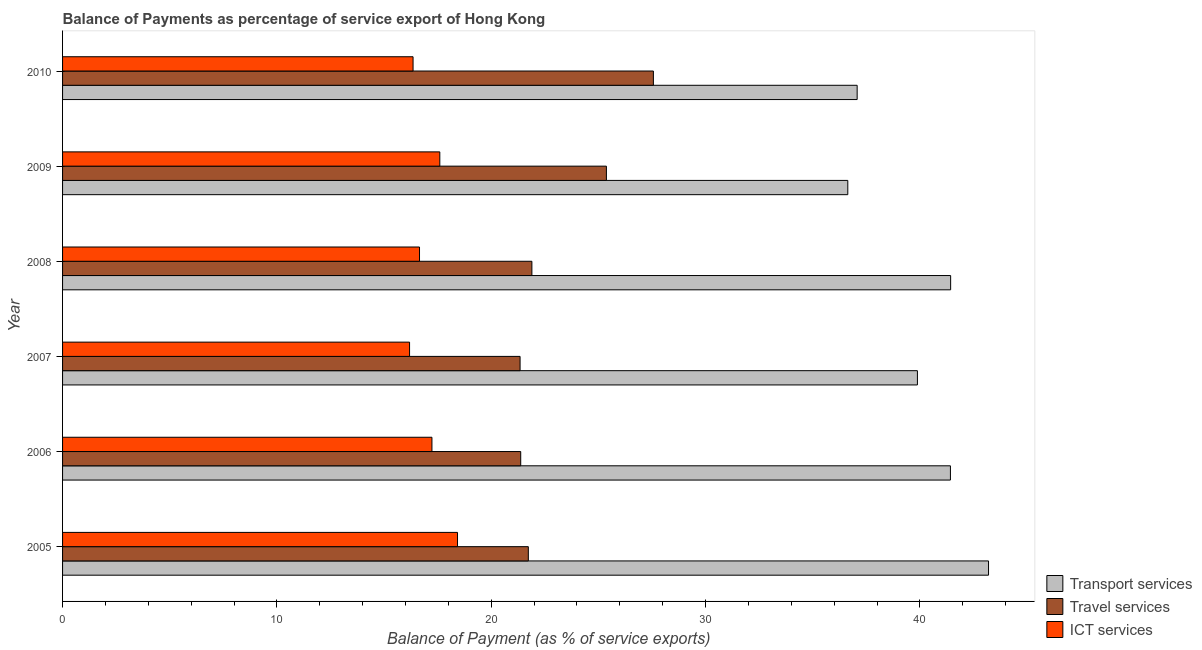How many groups of bars are there?
Provide a short and direct response. 6. Are the number of bars on each tick of the Y-axis equal?
Your answer should be very brief. Yes. How many bars are there on the 6th tick from the top?
Offer a terse response. 3. How many bars are there on the 2nd tick from the bottom?
Your answer should be compact. 3. What is the balance of payment of transport services in 2010?
Your answer should be very brief. 37.07. Across all years, what is the maximum balance of payment of ict services?
Give a very brief answer. 18.43. Across all years, what is the minimum balance of payment of ict services?
Your answer should be compact. 16.19. In which year was the balance of payment of transport services maximum?
Your answer should be very brief. 2005. In which year was the balance of payment of travel services minimum?
Provide a succinct answer. 2007. What is the total balance of payment of ict services in the graph?
Provide a succinct answer. 102.45. What is the difference between the balance of payment of transport services in 2005 and that in 2008?
Ensure brevity in your answer.  1.77. What is the difference between the balance of payment of transport services in 2006 and the balance of payment of travel services in 2008?
Give a very brief answer. 19.53. What is the average balance of payment of travel services per year?
Provide a short and direct response. 23.21. In the year 2010, what is the difference between the balance of payment of transport services and balance of payment of travel services?
Ensure brevity in your answer.  9.51. In how many years, is the balance of payment of ict services greater than 32 %?
Keep it short and to the point. 0. What is the ratio of the balance of payment of travel services in 2009 to that in 2010?
Your answer should be compact. 0.92. Is the difference between the balance of payment of transport services in 2006 and 2007 greater than the difference between the balance of payment of ict services in 2006 and 2007?
Make the answer very short. Yes. What is the difference between the highest and the second highest balance of payment of travel services?
Offer a terse response. 2.19. What is the difference between the highest and the lowest balance of payment of transport services?
Your response must be concise. 6.57. Is the sum of the balance of payment of transport services in 2006 and 2008 greater than the maximum balance of payment of travel services across all years?
Ensure brevity in your answer.  Yes. What does the 3rd bar from the top in 2006 represents?
Make the answer very short. Transport services. What does the 3rd bar from the bottom in 2005 represents?
Keep it short and to the point. ICT services. Is it the case that in every year, the sum of the balance of payment of transport services and balance of payment of travel services is greater than the balance of payment of ict services?
Keep it short and to the point. Yes. How many years are there in the graph?
Offer a very short reply. 6. What is the difference between two consecutive major ticks on the X-axis?
Your answer should be very brief. 10. Does the graph contain any zero values?
Give a very brief answer. No. Does the graph contain grids?
Give a very brief answer. No. How are the legend labels stacked?
Provide a short and direct response. Vertical. What is the title of the graph?
Your answer should be very brief. Balance of Payments as percentage of service export of Hong Kong. Does "Grants" appear as one of the legend labels in the graph?
Provide a short and direct response. No. What is the label or title of the X-axis?
Keep it short and to the point. Balance of Payment (as % of service exports). What is the label or title of the Y-axis?
Your response must be concise. Year. What is the Balance of Payment (as % of service exports) in Transport services in 2005?
Provide a succinct answer. 43.2. What is the Balance of Payment (as % of service exports) in Travel services in 2005?
Ensure brevity in your answer.  21.73. What is the Balance of Payment (as % of service exports) of ICT services in 2005?
Ensure brevity in your answer.  18.43. What is the Balance of Payment (as % of service exports) of Transport services in 2006?
Provide a succinct answer. 41.42. What is the Balance of Payment (as % of service exports) in Travel services in 2006?
Your response must be concise. 21.37. What is the Balance of Payment (as % of service exports) in ICT services in 2006?
Offer a very short reply. 17.23. What is the Balance of Payment (as % of service exports) in Transport services in 2007?
Provide a short and direct response. 39.88. What is the Balance of Payment (as % of service exports) in Travel services in 2007?
Ensure brevity in your answer.  21.34. What is the Balance of Payment (as % of service exports) in ICT services in 2007?
Provide a succinct answer. 16.19. What is the Balance of Payment (as % of service exports) of Transport services in 2008?
Make the answer very short. 41.43. What is the Balance of Payment (as % of service exports) of Travel services in 2008?
Offer a terse response. 21.9. What is the Balance of Payment (as % of service exports) in ICT services in 2008?
Provide a succinct answer. 16.65. What is the Balance of Payment (as % of service exports) of Transport services in 2009?
Keep it short and to the point. 36.63. What is the Balance of Payment (as % of service exports) of Travel services in 2009?
Provide a succinct answer. 25.37. What is the Balance of Payment (as % of service exports) in ICT services in 2009?
Your answer should be very brief. 17.6. What is the Balance of Payment (as % of service exports) in Transport services in 2010?
Your answer should be very brief. 37.07. What is the Balance of Payment (as % of service exports) in Travel services in 2010?
Offer a very short reply. 27.56. What is the Balance of Payment (as % of service exports) of ICT services in 2010?
Ensure brevity in your answer.  16.35. Across all years, what is the maximum Balance of Payment (as % of service exports) in Transport services?
Ensure brevity in your answer.  43.2. Across all years, what is the maximum Balance of Payment (as % of service exports) of Travel services?
Offer a very short reply. 27.56. Across all years, what is the maximum Balance of Payment (as % of service exports) of ICT services?
Make the answer very short. 18.43. Across all years, what is the minimum Balance of Payment (as % of service exports) in Transport services?
Ensure brevity in your answer.  36.63. Across all years, what is the minimum Balance of Payment (as % of service exports) of Travel services?
Your answer should be compact. 21.34. Across all years, what is the minimum Balance of Payment (as % of service exports) of ICT services?
Ensure brevity in your answer.  16.19. What is the total Balance of Payment (as % of service exports) of Transport services in the graph?
Your response must be concise. 239.64. What is the total Balance of Payment (as % of service exports) in Travel services in the graph?
Provide a succinct answer. 139.28. What is the total Balance of Payment (as % of service exports) of ICT services in the graph?
Your response must be concise. 102.45. What is the difference between the Balance of Payment (as % of service exports) in Transport services in 2005 and that in 2006?
Provide a short and direct response. 1.78. What is the difference between the Balance of Payment (as % of service exports) in Travel services in 2005 and that in 2006?
Your response must be concise. 0.36. What is the difference between the Balance of Payment (as % of service exports) in ICT services in 2005 and that in 2006?
Your response must be concise. 1.19. What is the difference between the Balance of Payment (as % of service exports) in Transport services in 2005 and that in 2007?
Give a very brief answer. 3.32. What is the difference between the Balance of Payment (as % of service exports) of Travel services in 2005 and that in 2007?
Give a very brief answer. 0.39. What is the difference between the Balance of Payment (as % of service exports) in ICT services in 2005 and that in 2007?
Your answer should be compact. 2.24. What is the difference between the Balance of Payment (as % of service exports) of Transport services in 2005 and that in 2008?
Keep it short and to the point. 1.77. What is the difference between the Balance of Payment (as % of service exports) in Travel services in 2005 and that in 2008?
Offer a very short reply. -0.17. What is the difference between the Balance of Payment (as % of service exports) in ICT services in 2005 and that in 2008?
Offer a terse response. 1.77. What is the difference between the Balance of Payment (as % of service exports) of Transport services in 2005 and that in 2009?
Your answer should be compact. 6.57. What is the difference between the Balance of Payment (as % of service exports) of Travel services in 2005 and that in 2009?
Give a very brief answer. -3.64. What is the difference between the Balance of Payment (as % of service exports) in ICT services in 2005 and that in 2009?
Your response must be concise. 0.83. What is the difference between the Balance of Payment (as % of service exports) of Transport services in 2005 and that in 2010?
Offer a very short reply. 6.13. What is the difference between the Balance of Payment (as % of service exports) of Travel services in 2005 and that in 2010?
Provide a succinct answer. -5.83. What is the difference between the Balance of Payment (as % of service exports) of ICT services in 2005 and that in 2010?
Ensure brevity in your answer.  2.07. What is the difference between the Balance of Payment (as % of service exports) of Transport services in 2006 and that in 2007?
Your answer should be compact. 1.54. What is the difference between the Balance of Payment (as % of service exports) in Travel services in 2006 and that in 2007?
Provide a short and direct response. 0.03. What is the difference between the Balance of Payment (as % of service exports) in ICT services in 2006 and that in 2007?
Keep it short and to the point. 1.04. What is the difference between the Balance of Payment (as % of service exports) of Transport services in 2006 and that in 2008?
Ensure brevity in your answer.  -0.01. What is the difference between the Balance of Payment (as % of service exports) of Travel services in 2006 and that in 2008?
Make the answer very short. -0.52. What is the difference between the Balance of Payment (as % of service exports) in ICT services in 2006 and that in 2008?
Ensure brevity in your answer.  0.58. What is the difference between the Balance of Payment (as % of service exports) of Transport services in 2006 and that in 2009?
Your response must be concise. 4.79. What is the difference between the Balance of Payment (as % of service exports) in Travel services in 2006 and that in 2009?
Make the answer very short. -4. What is the difference between the Balance of Payment (as % of service exports) of ICT services in 2006 and that in 2009?
Ensure brevity in your answer.  -0.37. What is the difference between the Balance of Payment (as % of service exports) in Transport services in 2006 and that in 2010?
Give a very brief answer. 4.35. What is the difference between the Balance of Payment (as % of service exports) in Travel services in 2006 and that in 2010?
Provide a short and direct response. -6.19. What is the difference between the Balance of Payment (as % of service exports) of ICT services in 2006 and that in 2010?
Offer a very short reply. 0.88. What is the difference between the Balance of Payment (as % of service exports) in Transport services in 2007 and that in 2008?
Keep it short and to the point. -1.55. What is the difference between the Balance of Payment (as % of service exports) in Travel services in 2007 and that in 2008?
Your answer should be compact. -0.55. What is the difference between the Balance of Payment (as % of service exports) of ICT services in 2007 and that in 2008?
Provide a short and direct response. -0.46. What is the difference between the Balance of Payment (as % of service exports) of Transport services in 2007 and that in 2009?
Your response must be concise. 3.25. What is the difference between the Balance of Payment (as % of service exports) of Travel services in 2007 and that in 2009?
Provide a succinct answer. -4.03. What is the difference between the Balance of Payment (as % of service exports) in ICT services in 2007 and that in 2009?
Make the answer very short. -1.41. What is the difference between the Balance of Payment (as % of service exports) of Transport services in 2007 and that in 2010?
Your answer should be compact. 2.81. What is the difference between the Balance of Payment (as % of service exports) in Travel services in 2007 and that in 2010?
Offer a terse response. -6.22. What is the difference between the Balance of Payment (as % of service exports) in ICT services in 2007 and that in 2010?
Provide a short and direct response. -0.16. What is the difference between the Balance of Payment (as % of service exports) in Transport services in 2008 and that in 2009?
Make the answer very short. 4.8. What is the difference between the Balance of Payment (as % of service exports) in Travel services in 2008 and that in 2009?
Offer a very short reply. -3.48. What is the difference between the Balance of Payment (as % of service exports) in ICT services in 2008 and that in 2009?
Offer a very short reply. -0.95. What is the difference between the Balance of Payment (as % of service exports) in Transport services in 2008 and that in 2010?
Your response must be concise. 4.36. What is the difference between the Balance of Payment (as % of service exports) of Travel services in 2008 and that in 2010?
Provide a short and direct response. -5.67. What is the difference between the Balance of Payment (as % of service exports) in ICT services in 2008 and that in 2010?
Provide a short and direct response. 0.3. What is the difference between the Balance of Payment (as % of service exports) in Transport services in 2009 and that in 2010?
Your response must be concise. -0.44. What is the difference between the Balance of Payment (as % of service exports) in Travel services in 2009 and that in 2010?
Your answer should be compact. -2.19. What is the difference between the Balance of Payment (as % of service exports) of ICT services in 2009 and that in 2010?
Make the answer very short. 1.25. What is the difference between the Balance of Payment (as % of service exports) in Transport services in 2005 and the Balance of Payment (as % of service exports) in Travel services in 2006?
Ensure brevity in your answer.  21.83. What is the difference between the Balance of Payment (as % of service exports) in Transport services in 2005 and the Balance of Payment (as % of service exports) in ICT services in 2006?
Provide a succinct answer. 25.97. What is the difference between the Balance of Payment (as % of service exports) of Travel services in 2005 and the Balance of Payment (as % of service exports) of ICT services in 2006?
Provide a short and direct response. 4.5. What is the difference between the Balance of Payment (as % of service exports) in Transport services in 2005 and the Balance of Payment (as % of service exports) in Travel services in 2007?
Offer a terse response. 21.86. What is the difference between the Balance of Payment (as % of service exports) of Transport services in 2005 and the Balance of Payment (as % of service exports) of ICT services in 2007?
Provide a succinct answer. 27.01. What is the difference between the Balance of Payment (as % of service exports) in Travel services in 2005 and the Balance of Payment (as % of service exports) in ICT services in 2007?
Provide a succinct answer. 5.54. What is the difference between the Balance of Payment (as % of service exports) of Transport services in 2005 and the Balance of Payment (as % of service exports) of Travel services in 2008?
Your answer should be very brief. 21.3. What is the difference between the Balance of Payment (as % of service exports) in Transport services in 2005 and the Balance of Payment (as % of service exports) in ICT services in 2008?
Keep it short and to the point. 26.55. What is the difference between the Balance of Payment (as % of service exports) of Travel services in 2005 and the Balance of Payment (as % of service exports) of ICT services in 2008?
Your response must be concise. 5.08. What is the difference between the Balance of Payment (as % of service exports) of Transport services in 2005 and the Balance of Payment (as % of service exports) of Travel services in 2009?
Your answer should be very brief. 17.83. What is the difference between the Balance of Payment (as % of service exports) of Transport services in 2005 and the Balance of Payment (as % of service exports) of ICT services in 2009?
Keep it short and to the point. 25.6. What is the difference between the Balance of Payment (as % of service exports) in Travel services in 2005 and the Balance of Payment (as % of service exports) in ICT services in 2009?
Offer a very short reply. 4.13. What is the difference between the Balance of Payment (as % of service exports) of Transport services in 2005 and the Balance of Payment (as % of service exports) of Travel services in 2010?
Your answer should be very brief. 15.64. What is the difference between the Balance of Payment (as % of service exports) of Transport services in 2005 and the Balance of Payment (as % of service exports) of ICT services in 2010?
Keep it short and to the point. 26.85. What is the difference between the Balance of Payment (as % of service exports) of Travel services in 2005 and the Balance of Payment (as % of service exports) of ICT services in 2010?
Offer a very short reply. 5.38. What is the difference between the Balance of Payment (as % of service exports) of Transport services in 2006 and the Balance of Payment (as % of service exports) of Travel services in 2007?
Your answer should be compact. 20.08. What is the difference between the Balance of Payment (as % of service exports) of Transport services in 2006 and the Balance of Payment (as % of service exports) of ICT services in 2007?
Give a very brief answer. 25.23. What is the difference between the Balance of Payment (as % of service exports) in Travel services in 2006 and the Balance of Payment (as % of service exports) in ICT services in 2007?
Offer a terse response. 5.19. What is the difference between the Balance of Payment (as % of service exports) of Transport services in 2006 and the Balance of Payment (as % of service exports) of Travel services in 2008?
Provide a succinct answer. 19.53. What is the difference between the Balance of Payment (as % of service exports) of Transport services in 2006 and the Balance of Payment (as % of service exports) of ICT services in 2008?
Ensure brevity in your answer.  24.77. What is the difference between the Balance of Payment (as % of service exports) in Travel services in 2006 and the Balance of Payment (as % of service exports) in ICT services in 2008?
Your answer should be compact. 4.72. What is the difference between the Balance of Payment (as % of service exports) in Transport services in 2006 and the Balance of Payment (as % of service exports) in Travel services in 2009?
Provide a succinct answer. 16.05. What is the difference between the Balance of Payment (as % of service exports) of Transport services in 2006 and the Balance of Payment (as % of service exports) of ICT services in 2009?
Keep it short and to the point. 23.82. What is the difference between the Balance of Payment (as % of service exports) of Travel services in 2006 and the Balance of Payment (as % of service exports) of ICT services in 2009?
Provide a succinct answer. 3.77. What is the difference between the Balance of Payment (as % of service exports) in Transport services in 2006 and the Balance of Payment (as % of service exports) in Travel services in 2010?
Provide a succinct answer. 13.86. What is the difference between the Balance of Payment (as % of service exports) in Transport services in 2006 and the Balance of Payment (as % of service exports) in ICT services in 2010?
Provide a short and direct response. 25.07. What is the difference between the Balance of Payment (as % of service exports) of Travel services in 2006 and the Balance of Payment (as % of service exports) of ICT services in 2010?
Provide a short and direct response. 5.02. What is the difference between the Balance of Payment (as % of service exports) of Transport services in 2007 and the Balance of Payment (as % of service exports) of Travel services in 2008?
Offer a terse response. 17.99. What is the difference between the Balance of Payment (as % of service exports) in Transport services in 2007 and the Balance of Payment (as % of service exports) in ICT services in 2008?
Provide a short and direct response. 23.23. What is the difference between the Balance of Payment (as % of service exports) of Travel services in 2007 and the Balance of Payment (as % of service exports) of ICT services in 2008?
Your answer should be compact. 4.69. What is the difference between the Balance of Payment (as % of service exports) of Transport services in 2007 and the Balance of Payment (as % of service exports) of Travel services in 2009?
Make the answer very short. 14.51. What is the difference between the Balance of Payment (as % of service exports) in Transport services in 2007 and the Balance of Payment (as % of service exports) in ICT services in 2009?
Provide a succinct answer. 22.28. What is the difference between the Balance of Payment (as % of service exports) of Travel services in 2007 and the Balance of Payment (as % of service exports) of ICT services in 2009?
Make the answer very short. 3.75. What is the difference between the Balance of Payment (as % of service exports) of Transport services in 2007 and the Balance of Payment (as % of service exports) of Travel services in 2010?
Provide a succinct answer. 12.32. What is the difference between the Balance of Payment (as % of service exports) in Transport services in 2007 and the Balance of Payment (as % of service exports) in ICT services in 2010?
Your answer should be compact. 23.53. What is the difference between the Balance of Payment (as % of service exports) in Travel services in 2007 and the Balance of Payment (as % of service exports) in ICT services in 2010?
Provide a short and direct response. 4.99. What is the difference between the Balance of Payment (as % of service exports) in Transport services in 2008 and the Balance of Payment (as % of service exports) in Travel services in 2009?
Provide a succinct answer. 16.06. What is the difference between the Balance of Payment (as % of service exports) of Transport services in 2008 and the Balance of Payment (as % of service exports) of ICT services in 2009?
Ensure brevity in your answer.  23.83. What is the difference between the Balance of Payment (as % of service exports) in Travel services in 2008 and the Balance of Payment (as % of service exports) in ICT services in 2009?
Give a very brief answer. 4.3. What is the difference between the Balance of Payment (as % of service exports) in Transport services in 2008 and the Balance of Payment (as % of service exports) in Travel services in 2010?
Keep it short and to the point. 13.87. What is the difference between the Balance of Payment (as % of service exports) of Transport services in 2008 and the Balance of Payment (as % of service exports) of ICT services in 2010?
Ensure brevity in your answer.  25.08. What is the difference between the Balance of Payment (as % of service exports) in Travel services in 2008 and the Balance of Payment (as % of service exports) in ICT services in 2010?
Offer a terse response. 5.54. What is the difference between the Balance of Payment (as % of service exports) of Transport services in 2009 and the Balance of Payment (as % of service exports) of Travel services in 2010?
Your response must be concise. 9.07. What is the difference between the Balance of Payment (as % of service exports) of Transport services in 2009 and the Balance of Payment (as % of service exports) of ICT services in 2010?
Make the answer very short. 20.28. What is the difference between the Balance of Payment (as % of service exports) in Travel services in 2009 and the Balance of Payment (as % of service exports) in ICT services in 2010?
Offer a very short reply. 9.02. What is the average Balance of Payment (as % of service exports) in Transport services per year?
Make the answer very short. 39.94. What is the average Balance of Payment (as % of service exports) of Travel services per year?
Your answer should be compact. 23.21. What is the average Balance of Payment (as % of service exports) of ICT services per year?
Provide a succinct answer. 17.08. In the year 2005, what is the difference between the Balance of Payment (as % of service exports) of Transport services and Balance of Payment (as % of service exports) of Travel services?
Your answer should be very brief. 21.47. In the year 2005, what is the difference between the Balance of Payment (as % of service exports) in Transport services and Balance of Payment (as % of service exports) in ICT services?
Your answer should be very brief. 24.77. In the year 2005, what is the difference between the Balance of Payment (as % of service exports) of Travel services and Balance of Payment (as % of service exports) of ICT services?
Offer a terse response. 3.3. In the year 2006, what is the difference between the Balance of Payment (as % of service exports) of Transport services and Balance of Payment (as % of service exports) of Travel services?
Provide a short and direct response. 20.05. In the year 2006, what is the difference between the Balance of Payment (as % of service exports) of Transport services and Balance of Payment (as % of service exports) of ICT services?
Make the answer very short. 24.19. In the year 2006, what is the difference between the Balance of Payment (as % of service exports) in Travel services and Balance of Payment (as % of service exports) in ICT services?
Your answer should be very brief. 4.14. In the year 2007, what is the difference between the Balance of Payment (as % of service exports) in Transport services and Balance of Payment (as % of service exports) in Travel services?
Provide a short and direct response. 18.54. In the year 2007, what is the difference between the Balance of Payment (as % of service exports) in Transport services and Balance of Payment (as % of service exports) in ICT services?
Keep it short and to the point. 23.69. In the year 2007, what is the difference between the Balance of Payment (as % of service exports) in Travel services and Balance of Payment (as % of service exports) in ICT services?
Make the answer very short. 5.16. In the year 2008, what is the difference between the Balance of Payment (as % of service exports) in Transport services and Balance of Payment (as % of service exports) in Travel services?
Offer a terse response. 19.54. In the year 2008, what is the difference between the Balance of Payment (as % of service exports) in Transport services and Balance of Payment (as % of service exports) in ICT services?
Provide a succinct answer. 24.78. In the year 2008, what is the difference between the Balance of Payment (as % of service exports) of Travel services and Balance of Payment (as % of service exports) of ICT services?
Your answer should be compact. 5.24. In the year 2009, what is the difference between the Balance of Payment (as % of service exports) of Transport services and Balance of Payment (as % of service exports) of Travel services?
Provide a short and direct response. 11.26. In the year 2009, what is the difference between the Balance of Payment (as % of service exports) in Transport services and Balance of Payment (as % of service exports) in ICT services?
Provide a short and direct response. 19.03. In the year 2009, what is the difference between the Balance of Payment (as % of service exports) of Travel services and Balance of Payment (as % of service exports) of ICT services?
Your answer should be very brief. 7.77. In the year 2010, what is the difference between the Balance of Payment (as % of service exports) of Transport services and Balance of Payment (as % of service exports) of Travel services?
Your answer should be compact. 9.51. In the year 2010, what is the difference between the Balance of Payment (as % of service exports) in Transport services and Balance of Payment (as % of service exports) in ICT services?
Offer a very short reply. 20.72. In the year 2010, what is the difference between the Balance of Payment (as % of service exports) of Travel services and Balance of Payment (as % of service exports) of ICT services?
Make the answer very short. 11.21. What is the ratio of the Balance of Payment (as % of service exports) in Transport services in 2005 to that in 2006?
Your answer should be compact. 1.04. What is the ratio of the Balance of Payment (as % of service exports) in Travel services in 2005 to that in 2006?
Offer a very short reply. 1.02. What is the ratio of the Balance of Payment (as % of service exports) in ICT services in 2005 to that in 2006?
Your answer should be very brief. 1.07. What is the ratio of the Balance of Payment (as % of service exports) of Transport services in 2005 to that in 2007?
Your response must be concise. 1.08. What is the ratio of the Balance of Payment (as % of service exports) in ICT services in 2005 to that in 2007?
Your answer should be very brief. 1.14. What is the ratio of the Balance of Payment (as % of service exports) in Transport services in 2005 to that in 2008?
Ensure brevity in your answer.  1.04. What is the ratio of the Balance of Payment (as % of service exports) of Travel services in 2005 to that in 2008?
Your answer should be very brief. 0.99. What is the ratio of the Balance of Payment (as % of service exports) in ICT services in 2005 to that in 2008?
Provide a short and direct response. 1.11. What is the ratio of the Balance of Payment (as % of service exports) in Transport services in 2005 to that in 2009?
Provide a short and direct response. 1.18. What is the ratio of the Balance of Payment (as % of service exports) of Travel services in 2005 to that in 2009?
Make the answer very short. 0.86. What is the ratio of the Balance of Payment (as % of service exports) of ICT services in 2005 to that in 2009?
Provide a short and direct response. 1.05. What is the ratio of the Balance of Payment (as % of service exports) in Transport services in 2005 to that in 2010?
Give a very brief answer. 1.17. What is the ratio of the Balance of Payment (as % of service exports) in Travel services in 2005 to that in 2010?
Your response must be concise. 0.79. What is the ratio of the Balance of Payment (as % of service exports) of ICT services in 2005 to that in 2010?
Ensure brevity in your answer.  1.13. What is the ratio of the Balance of Payment (as % of service exports) of Transport services in 2006 to that in 2007?
Provide a short and direct response. 1.04. What is the ratio of the Balance of Payment (as % of service exports) of ICT services in 2006 to that in 2007?
Make the answer very short. 1.06. What is the ratio of the Balance of Payment (as % of service exports) in Travel services in 2006 to that in 2008?
Your answer should be compact. 0.98. What is the ratio of the Balance of Payment (as % of service exports) in ICT services in 2006 to that in 2008?
Provide a succinct answer. 1.03. What is the ratio of the Balance of Payment (as % of service exports) of Transport services in 2006 to that in 2009?
Give a very brief answer. 1.13. What is the ratio of the Balance of Payment (as % of service exports) in Travel services in 2006 to that in 2009?
Your answer should be very brief. 0.84. What is the ratio of the Balance of Payment (as % of service exports) in ICT services in 2006 to that in 2009?
Make the answer very short. 0.98. What is the ratio of the Balance of Payment (as % of service exports) of Transport services in 2006 to that in 2010?
Give a very brief answer. 1.12. What is the ratio of the Balance of Payment (as % of service exports) in Travel services in 2006 to that in 2010?
Provide a succinct answer. 0.78. What is the ratio of the Balance of Payment (as % of service exports) of ICT services in 2006 to that in 2010?
Provide a short and direct response. 1.05. What is the ratio of the Balance of Payment (as % of service exports) of Transport services in 2007 to that in 2008?
Offer a very short reply. 0.96. What is the ratio of the Balance of Payment (as % of service exports) in Travel services in 2007 to that in 2008?
Give a very brief answer. 0.97. What is the ratio of the Balance of Payment (as % of service exports) in ICT services in 2007 to that in 2008?
Offer a terse response. 0.97. What is the ratio of the Balance of Payment (as % of service exports) of Transport services in 2007 to that in 2009?
Offer a very short reply. 1.09. What is the ratio of the Balance of Payment (as % of service exports) in Travel services in 2007 to that in 2009?
Provide a short and direct response. 0.84. What is the ratio of the Balance of Payment (as % of service exports) of ICT services in 2007 to that in 2009?
Your answer should be compact. 0.92. What is the ratio of the Balance of Payment (as % of service exports) in Transport services in 2007 to that in 2010?
Offer a terse response. 1.08. What is the ratio of the Balance of Payment (as % of service exports) of Travel services in 2007 to that in 2010?
Your answer should be very brief. 0.77. What is the ratio of the Balance of Payment (as % of service exports) of Transport services in 2008 to that in 2009?
Your response must be concise. 1.13. What is the ratio of the Balance of Payment (as % of service exports) in Travel services in 2008 to that in 2009?
Give a very brief answer. 0.86. What is the ratio of the Balance of Payment (as % of service exports) in ICT services in 2008 to that in 2009?
Keep it short and to the point. 0.95. What is the ratio of the Balance of Payment (as % of service exports) in Transport services in 2008 to that in 2010?
Provide a short and direct response. 1.12. What is the ratio of the Balance of Payment (as % of service exports) in Travel services in 2008 to that in 2010?
Make the answer very short. 0.79. What is the ratio of the Balance of Payment (as % of service exports) in ICT services in 2008 to that in 2010?
Provide a short and direct response. 1.02. What is the ratio of the Balance of Payment (as % of service exports) in Travel services in 2009 to that in 2010?
Offer a very short reply. 0.92. What is the ratio of the Balance of Payment (as % of service exports) of ICT services in 2009 to that in 2010?
Give a very brief answer. 1.08. What is the difference between the highest and the second highest Balance of Payment (as % of service exports) in Transport services?
Provide a succinct answer. 1.77. What is the difference between the highest and the second highest Balance of Payment (as % of service exports) in Travel services?
Provide a succinct answer. 2.19. What is the difference between the highest and the second highest Balance of Payment (as % of service exports) of ICT services?
Ensure brevity in your answer.  0.83. What is the difference between the highest and the lowest Balance of Payment (as % of service exports) in Transport services?
Make the answer very short. 6.57. What is the difference between the highest and the lowest Balance of Payment (as % of service exports) in Travel services?
Provide a succinct answer. 6.22. What is the difference between the highest and the lowest Balance of Payment (as % of service exports) in ICT services?
Your response must be concise. 2.24. 